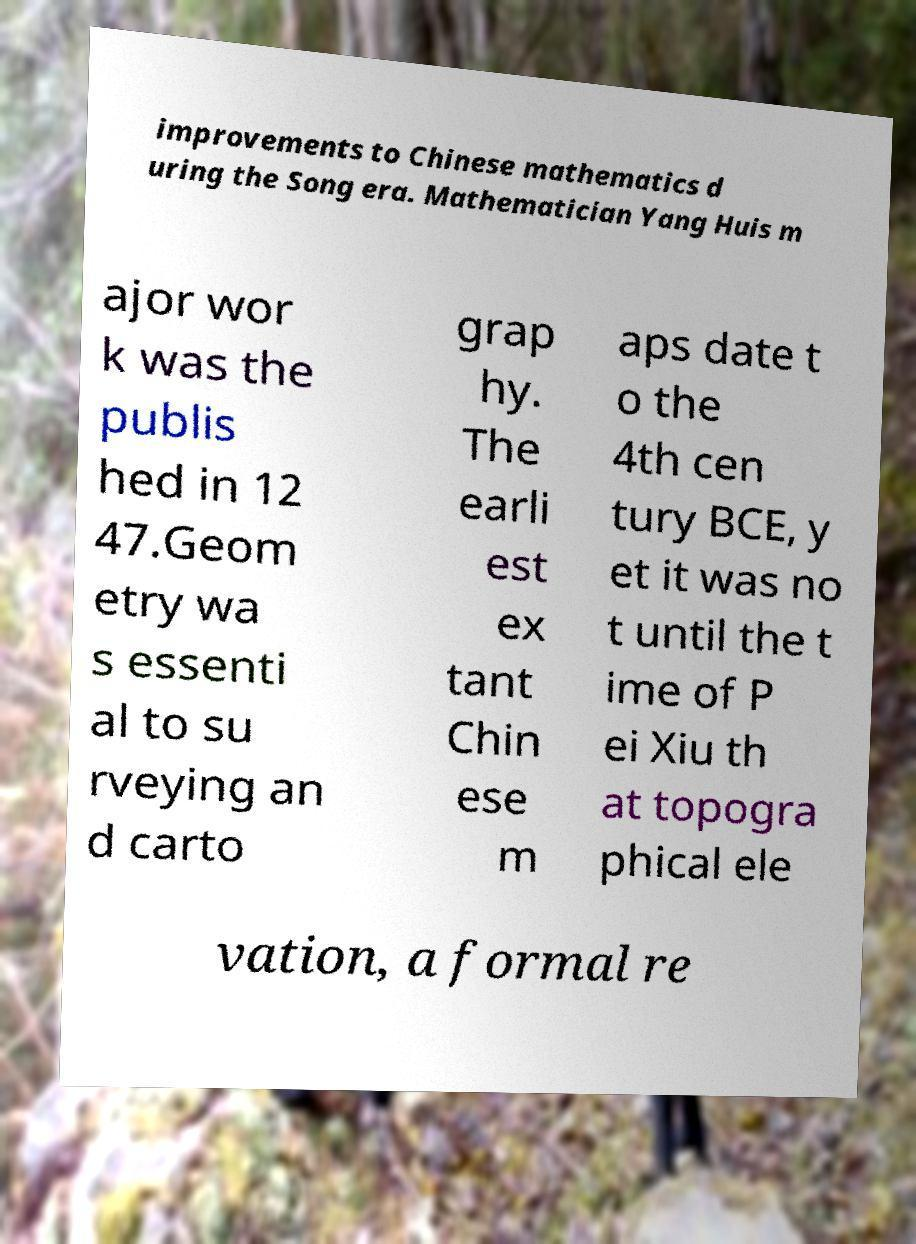Can you read and provide the text displayed in the image?This photo seems to have some interesting text. Can you extract and type it out for me? improvements to Chinese mathematics d uring the Song era. Mathematician Yang Huis m ajor wor k was the publis hed in 12 47.Geom etry wa s essenti al to su rveying an d carto grap hy. The earli est ex tant Chin ese m aps date t o the 4th cen tury BCE, y et it was no t until the t ime of P ei Xiu th at topogra phical ele vation, a formal re 